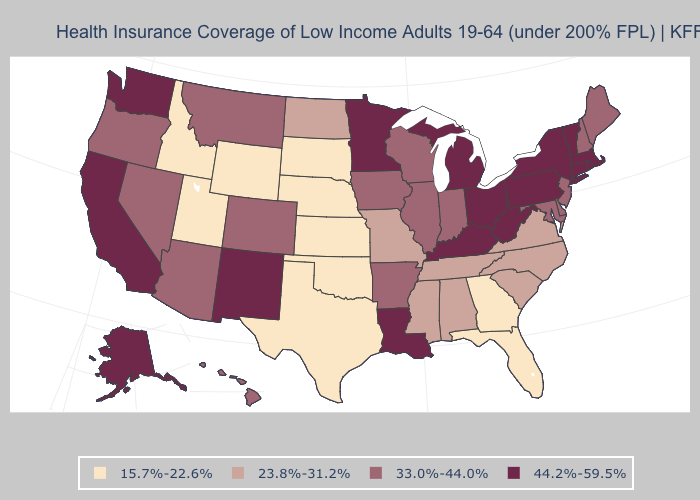Does the first symbol in the legend represent the smallest category?
Give a very brief answer. Yes. Which states have the lowest value in the USA?
Concise answer only. Florida, Georgia, Idaho, Kansas, Nebraska, Oklahoma, South Dakota, Texas, Utah, Wyoming. Which states have the highest value in the USA?
Be succinct. Alaska, California, Connecticut, Kentucky, Louisiana, Massachusetts, Michigan, Minnesota, New Mexico, New York, Ohio, Pennsylvania, Rhode Island, Vermont, Washington, West Virginia. Name the states that have a value in the range 23.8%-31.2%?
Write a very short answer. Alabama, Mississippi, Missouri, North Carolina, North Dakota, South Carolina, Tennessee, Virginia. Does Rhode Island have the highest value in the USA?
Concise answer only. Yes. Does Hawaii have the lowest value in the West?
Give a very brief answer. No. What is the highest value in the Northeast ?
Concise answer only. 44.2%-59.5%. Name the states that have a value in the range 15.7%-22.6%?
Quick response, please. Florida, Georgia, Idaho, Kansas, Nebraska, Oklahoma, South Dakota, Texas, Utah, Wyoming. Does Ohio have a lower value than Nevada?
Quick response, please. No. What is the lowest value in the MidWest?
Write a very short answer. 15.7%-22.6%. Which states hav the highest value in the South?
Short answer required. Kentucky, Louisiana, West Virginia. What is the lowest value in states that border Georgia?
Keep it brief. 15.7%-22.6%. Among the states that border Colorado , does New Mexico have the highest value?
Concise answer only. Yes. Does the first symbol in the legend represent the smallest category?
Write a very short answer. Yes. What is the value of Rhode Island?
Quick response, please. 44.2%-59.5%. 